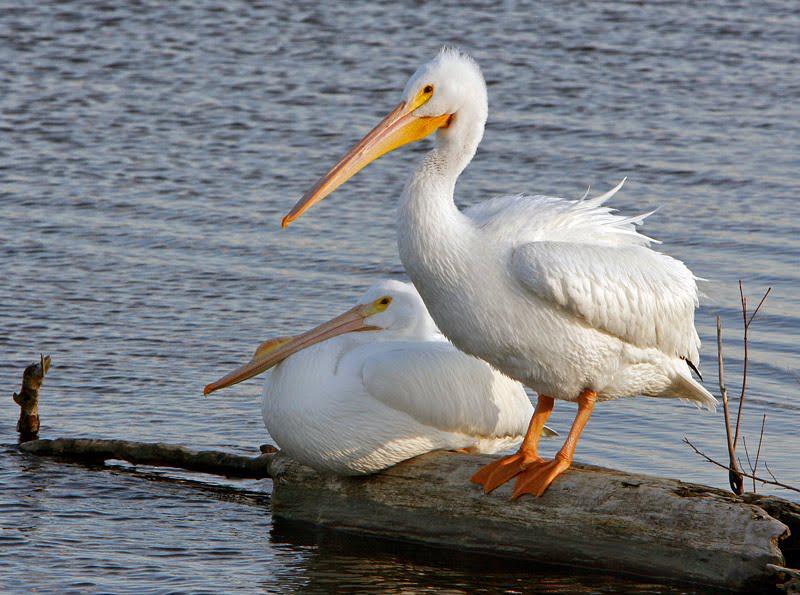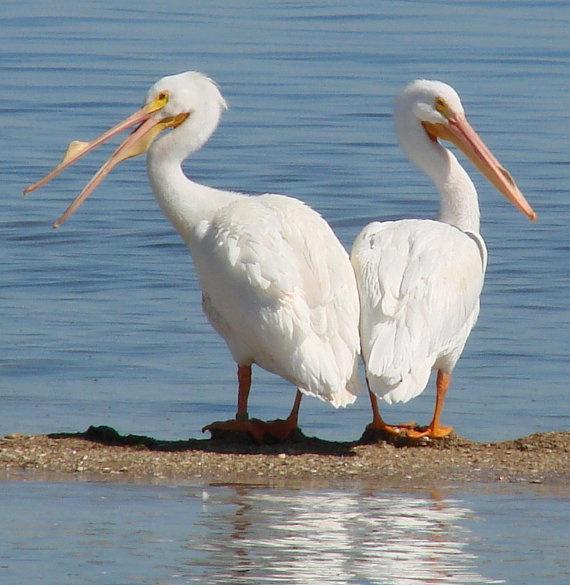The first image is the image on the left, the second image is the image on the right. Evaluate the accuracy of this statement regarding the images: "In one of the image two birds are on a log facing left.". Is it true? Answer yes or no. Yes. The first image is the image on the left, the second image is the image on the right. For the images shown, is this caption "One of the pelicans has a fish in its mouth." true? Answer yes or no. No. 